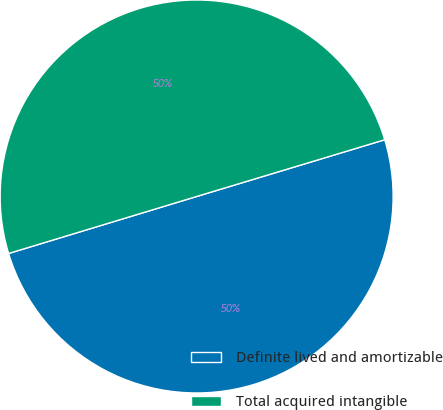Convert chart. <chart><loc_0><loc_0><loc_500><loc_500><pie_chart><fcel>Definite lived and amortizable<fcel>Total acquired intangible<nl><fcel>49.98%<fcel>50.02%<nl></chart> 